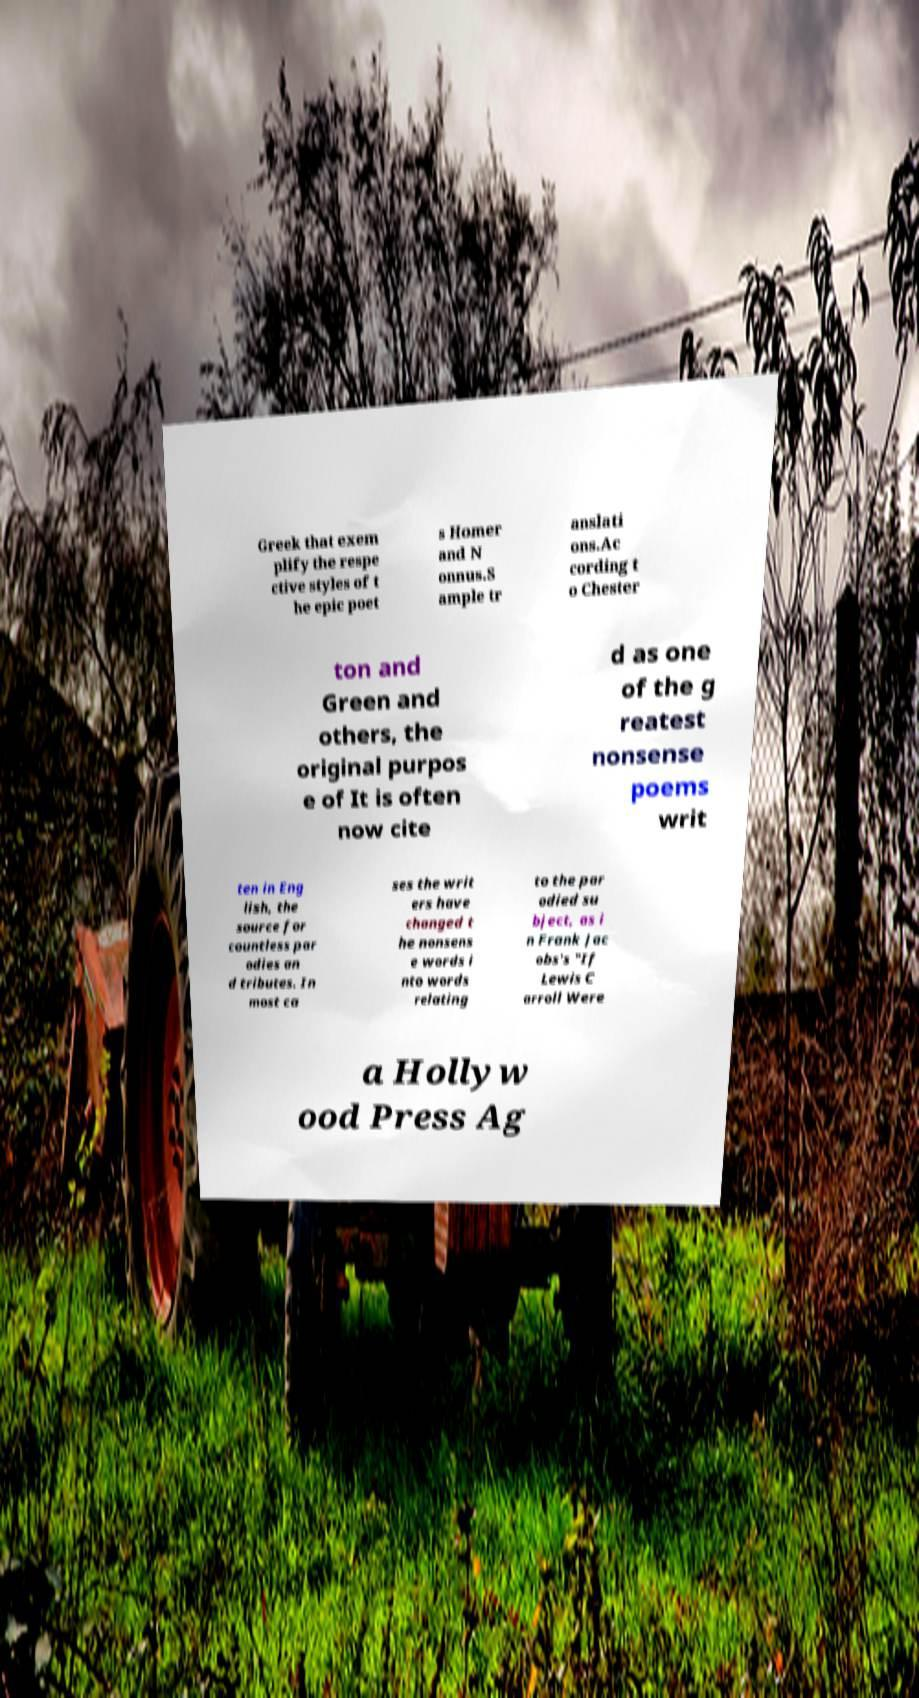What messages or text are displayed in this image? I need them in a readable, typed format. Greek that exem plify the respe ctive styles of t he epic poet s Homer and N onnus.S ample tr anslati ons.Ac cording t o Chester ton and Green and others, the original purpos e of It is often now cite d as one of the g reatest nonsense poems writ ten in Eng lish, the source for countless par odies an d tributes. In most ca ses the writ ers have changed t he nonsens e words i nto words relating to the par odied su bject, as i n Frank Jac obs's "If Lewis C arroll Were a Hollyw ood Press Ag 